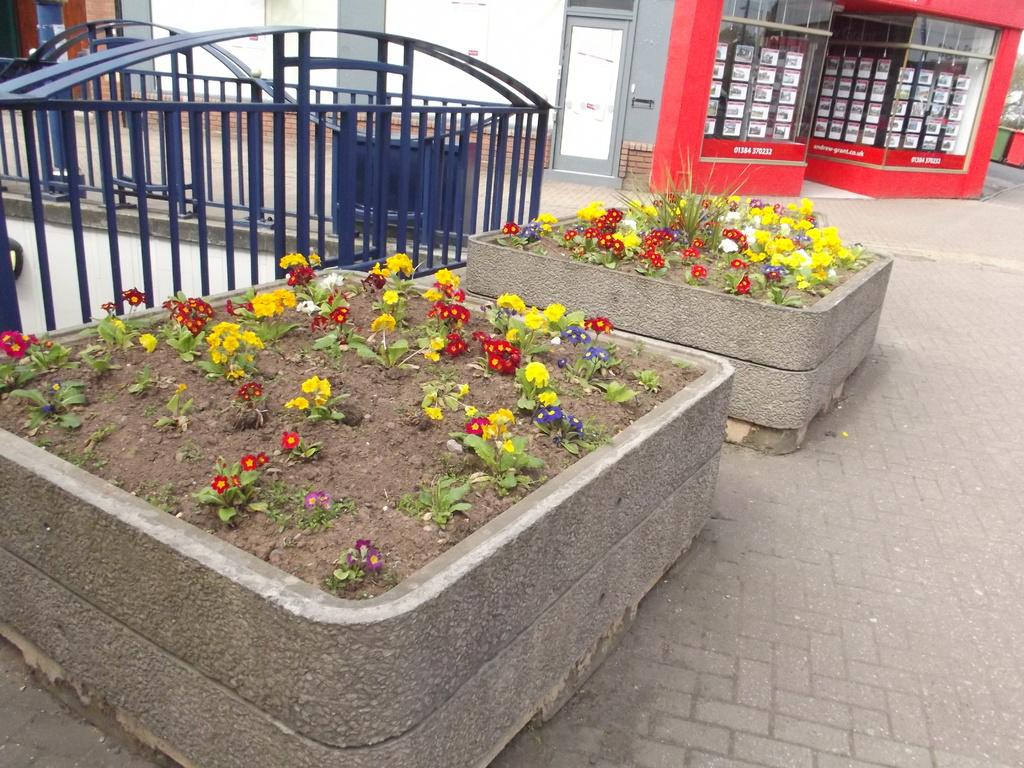What type of containers are on the ground in the image? There are concrete planters on the ground in the image. What is inside the planters? The planters contain soil. What is growing in the planters? The planters have plants with flowers in them. What can be seen in the background of the image? In the background of the image, there are fences, dustbins, doors, and other objects. What is the owner of the plants crying about in the image? There is no person or owner present in the image, and therefore no one is crying. 